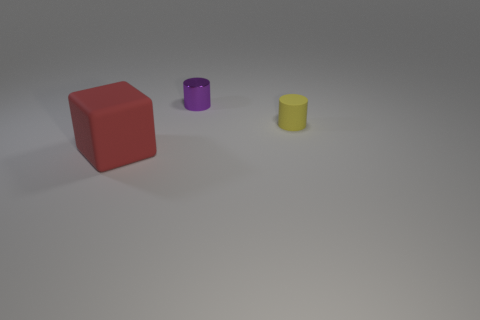Add 3 tiny purple cylinders. How many objects exist? 6 Subtract all blocks. How many objects are left? 2 Subtract all small objects. Subtract all shiny cylinders. How many objects are left? 0 Add 1 yellow objects. How many yellow objects are left? 2 Add 2 green rubber cylinders. How many green rubber cylinders exist? 2 Subtract 0 red balls. How many objects are left? 3 